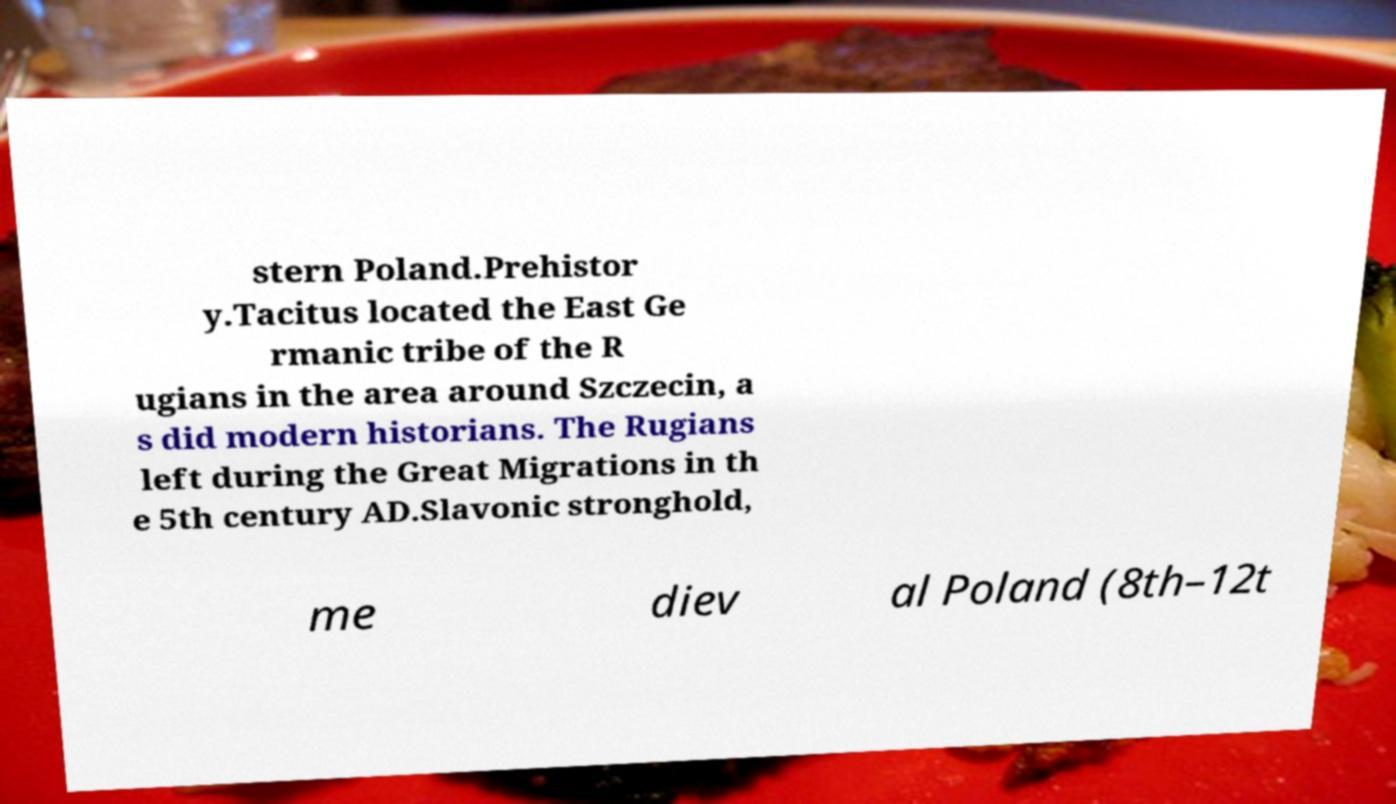I need the written content from this picture converted into text. Can you do that? stern Poland.Prehistor y.Tacitus located the East Ge rmanic tribe of the R ugians in the area around Szczecin, a s did modern historians. The Rugians left during the Great Migrations in th e 5th century AD.Slavonic stronghold, me diev al Poland (8th–12t 